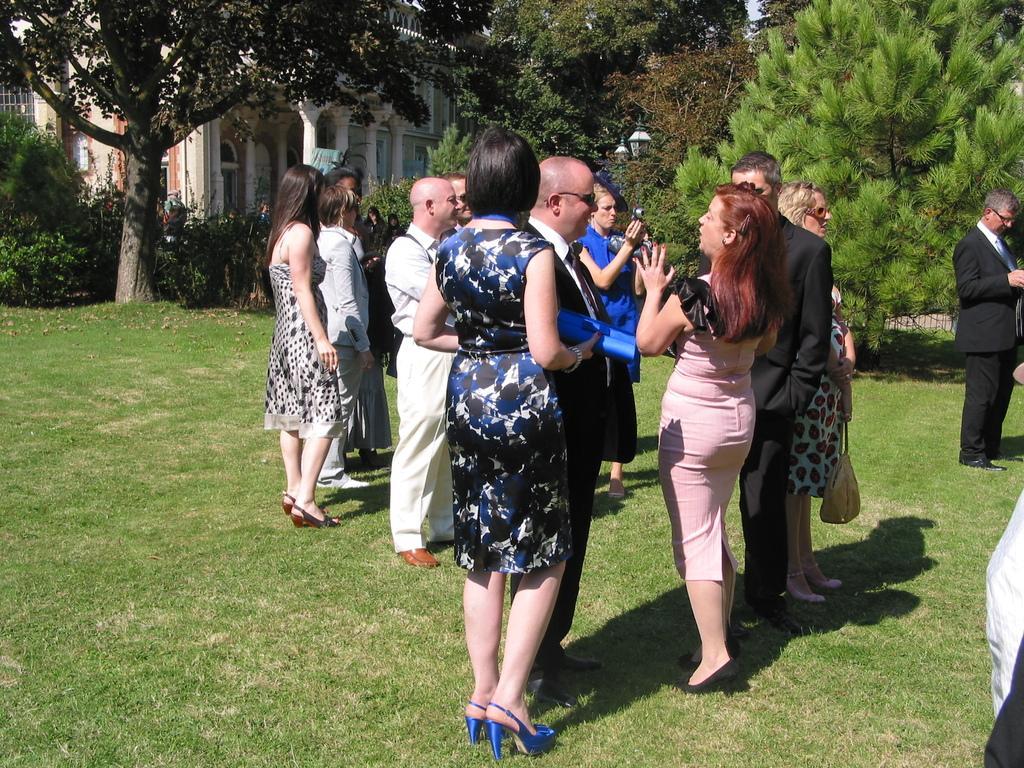How would you summarize this image in a sentence or two? As we can see in the image there are group of people here and there, camera, grass, trees and houses. 